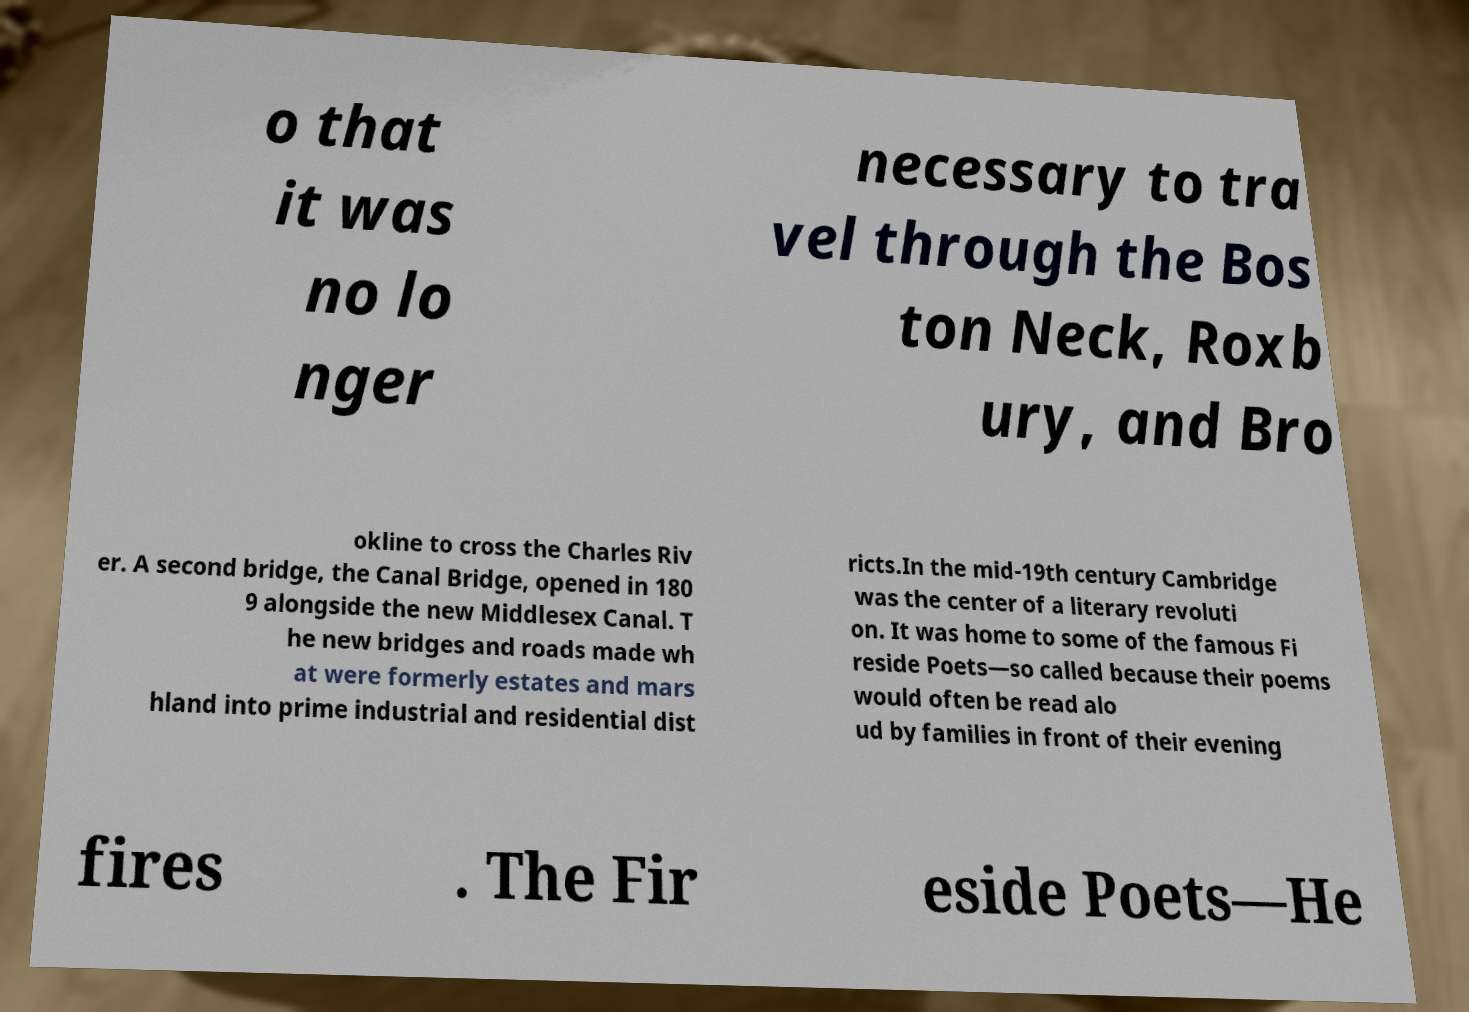Can you accurately transcribe the text from the provided image for me? o that it was no lo nger necessary to tra vel through the Bos ton Neck, Roxb ury, and Bro okline to cross the Charles Riv er. A second bridge, the Canal Bridge, opened in 180 9 alongside the new Middlesex Canal. T he new bridges and roads made wh at were formerly estates and mars hland into prime industrial and residential dist ricts.In the mid-19th century Cambridge was the center of a literary revoluti on. It was home to some of the famous Fi reside Poets—so called because their poems would often be read alo ud by families in front of their evening fires . The Fir eside Poets—He 